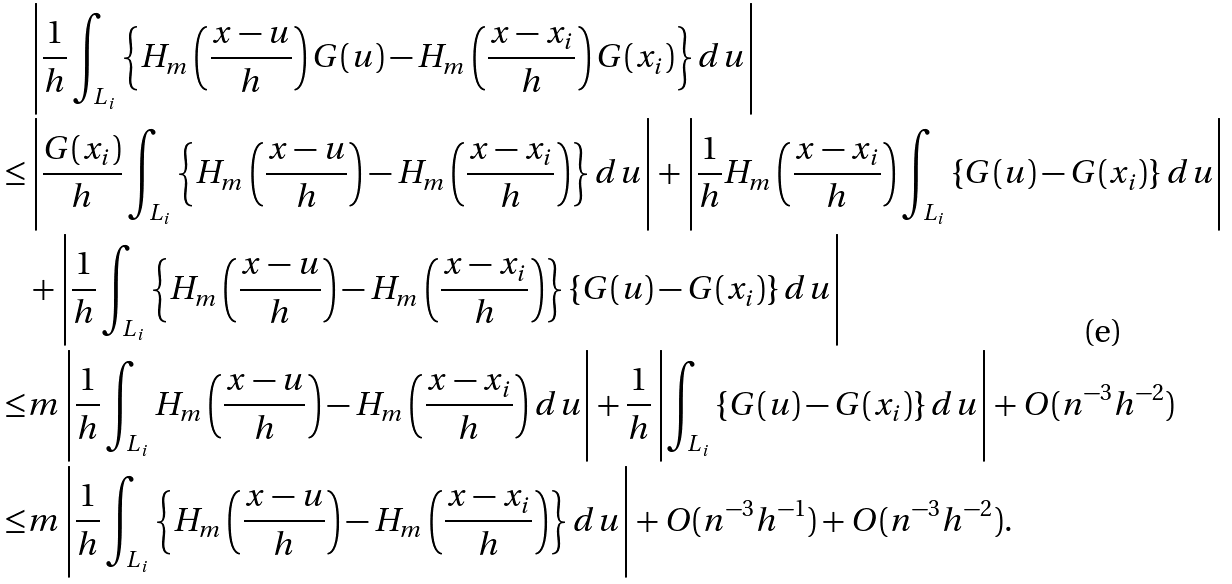<formula> <loc_0><loc_0><loc_500><loc_500>& \left | \frac { 1 } { h } \int _ { L _ { i } } \left \{ H _ { m } \left ( \frac { x - u } { h } \right ) G ( u ) - H _ { m } \left ( \frac { x - x _ { i } } { h } \right ) G ( x _ { i } ) \right \} d u \right | \\ \leq & \left | \frac { G ( x _ { i } ) } { h } \int _ { L _ { i } } \left \{ H _ { m } \left ( \frac { x - u } { h } \right ) - H _ { m } \left ( \frac { x - x _ { i } } { h } \right ) \right \} d u \right | + \left | \frac { 1 } { h } H _ { m } \left ( \frac { x - x _ { i } } { h } \right ) \int _ { L _ { i } } \left \{ G ( u ) - G ( x _ { i } ) \right \} d u \right | \\ & + \left | \frac { 1 } { h } \int _ { L _ { i } } \left \{ H _ { m } \left ( \frac { x - u } { h } \right ) - H _ { m } \left ( \frac { x - x _ { i } } { h } \right ) \right \} \left \{ G ( u ) - G ( x _ { i } ) \right \} d u \right | \\ \leq & m \left | \frac { 1 } { h } \int _ { L _ { i } } H _ { m } \left ( \frac { x - u } { h } \right ) - H _ { m } \left ( \frac { x - x _ { i } } { h } \right ) d u \right | + \frac { 1 } { h } \left | \int _ { L _ { i } } \left \{ G ( u ) - G ( x _ { i } ) \right \} d u \right | + O ( n ^ { - 3 } h ^ { - 2 } ) \\ \leq & m \left | \frac { 1 } { h } \int _ { L _ { i } } \left \{ H _ { m } \left ( \frac { x - u } { h } \right ) - H _ { m } \left ( \frac { x - x _ { i } } { h } \right ) \right \} d u \right | + O ( n ^ { - 3 } h ^ { - 1 } ) + O ( n ^ { - 3 } h ^ { - 2 } ) .</formula> 